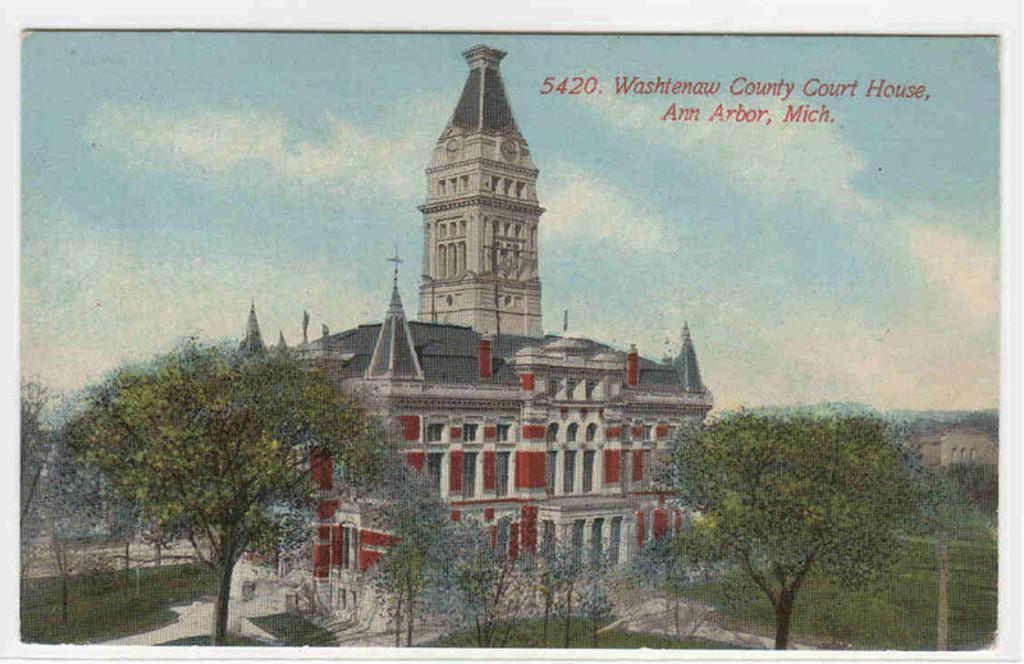How would you summarize this image in a sentence or two? This image looks like a poster. There is building in the middle. There are trees at the bottom. There is sky at the top. 